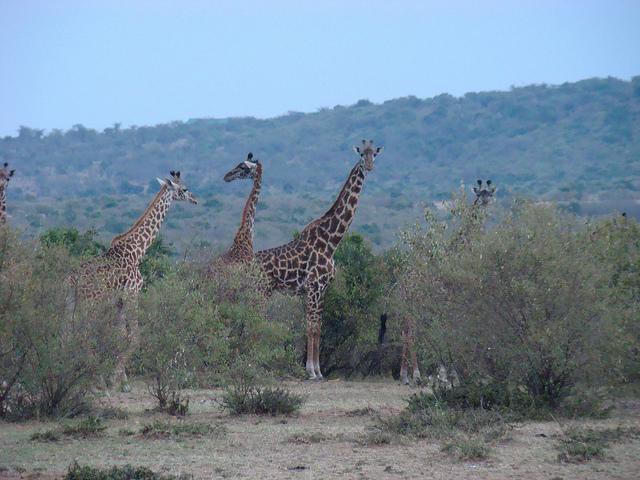How many giraffes are in the photo?
Give a very brief answer. 3. How many men are wearing a tie?
Give a very brief answer. 0. 